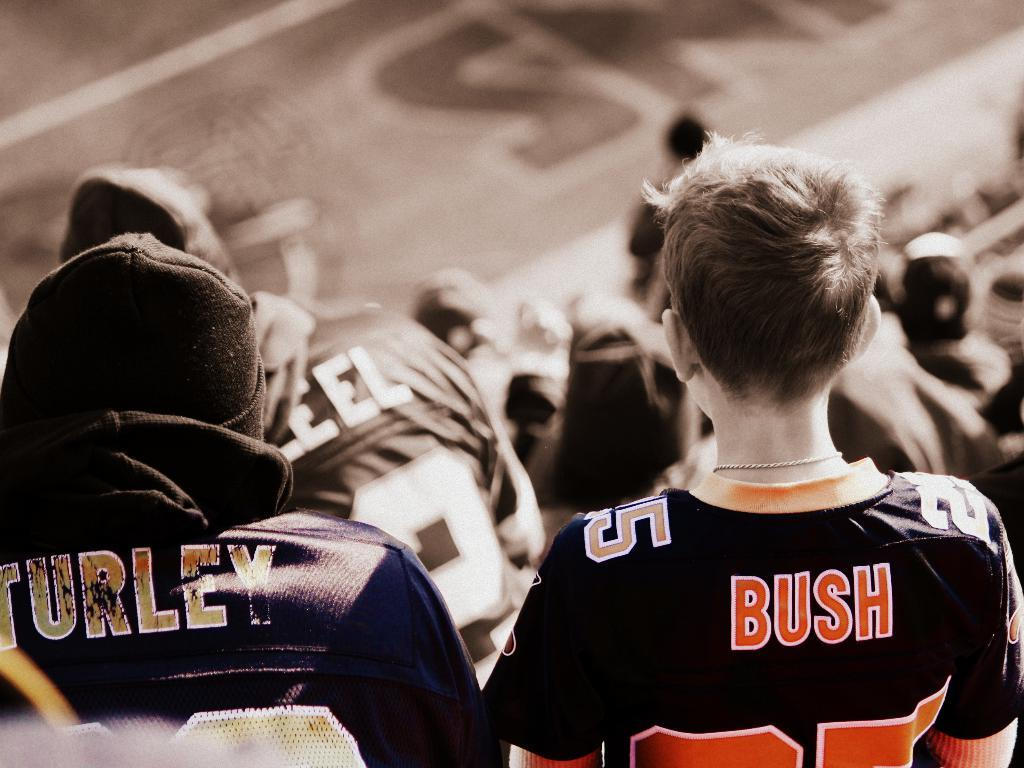<image>
Summarize the visual content of the image. A person with short hair has the name Bush on the back of their shirt. 